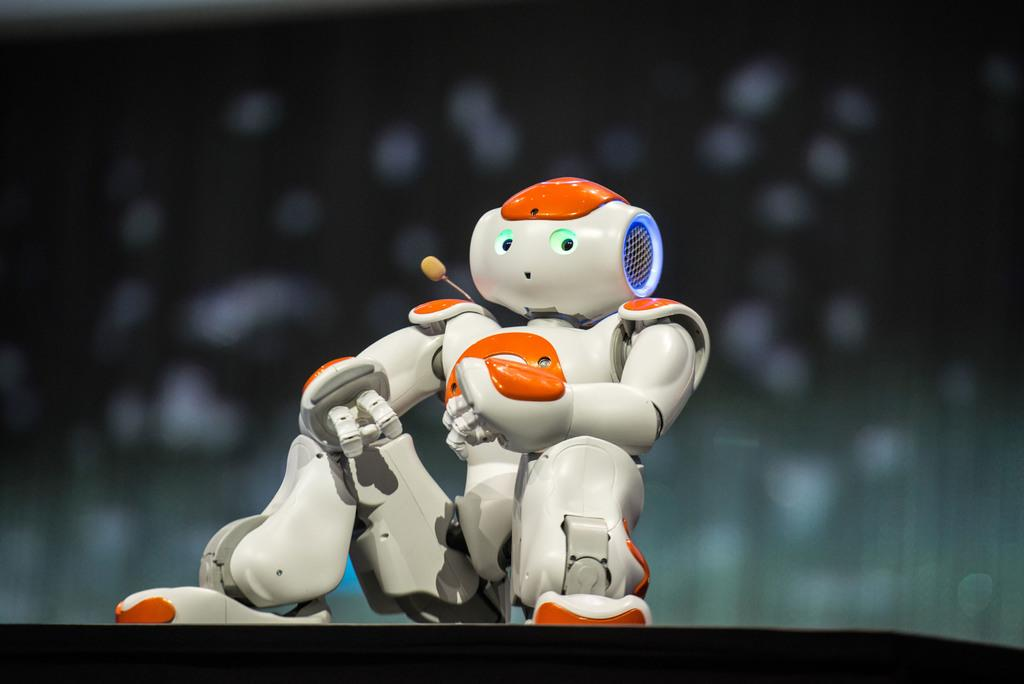What is the main subject in the center of the image? There is a robot in the center of the image. How many bones can be seen in the image? There are no bones present in the image; it features a robot. What is the size of the wing in the image? There is no wing present in the image; it features a robot. 